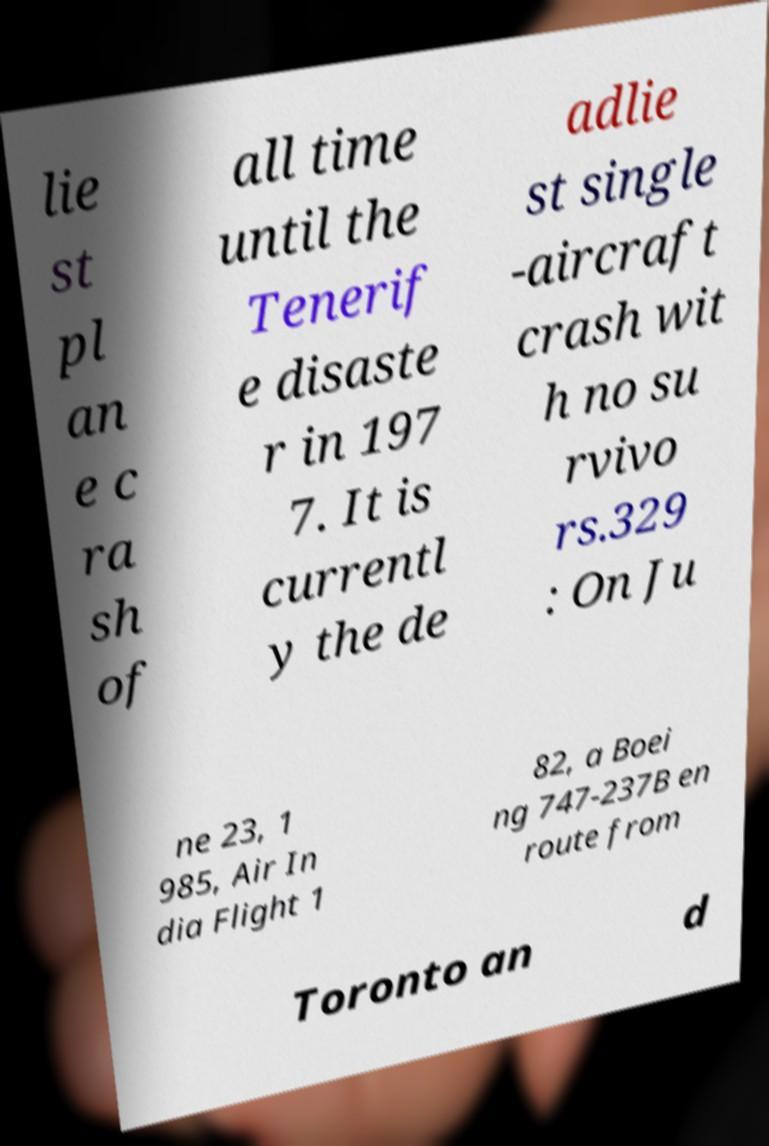Please read and relay the text visible in this image. What does it say? lie st pl an e c ra sh of all time until the Tenerif e disaste r in 197 7. It is currentl y the de adlie st single -aircraft crash wit h no su rvivo rs.329 : On Ju ne 23, 1 985, Air In dia Flight 1 82, a Boei ng 747-237B en route from Toronto an d 